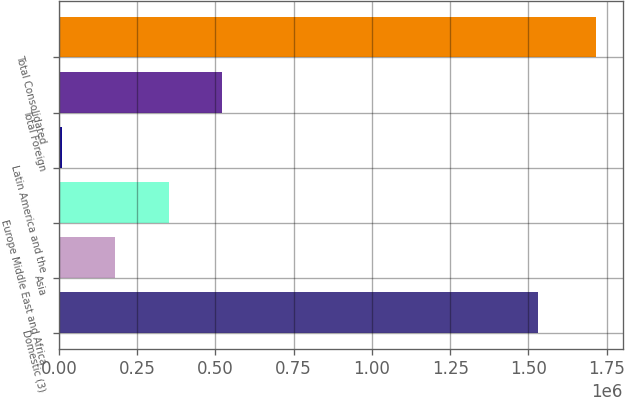<chart> <loc_0><loc_0><loc_500><loc_500><bar_chart><fcel>Domestic (3)<fcel>Asia<fcel>Europe Middle East and Africa<fcel>Latin America and the<fcel>Total Foreign<fcel>Total Consolidated<nl><fcel>1.5299e+06<fcel>180741<fcel>351297<fcel>10185<fcel>521853<fcel>1.71575e+06<nl></chart> 